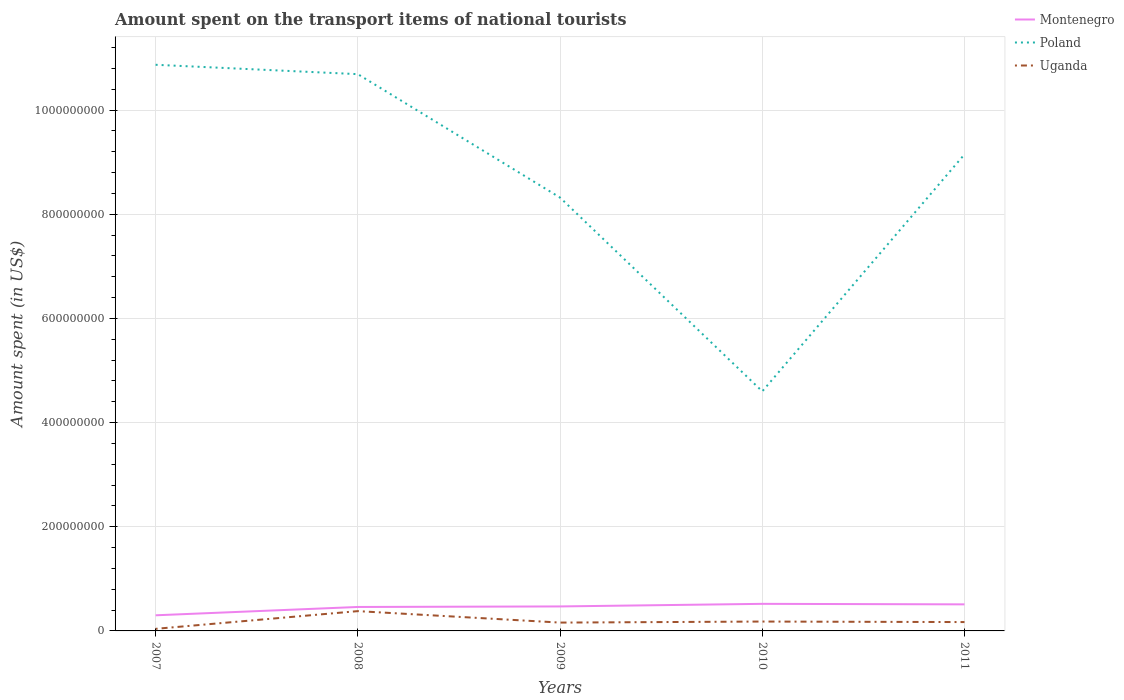How many different coloured lines are there?
Your response must be concise. 3. Is the number of lines equal to the number of legend labels?
Your answer should be compact. Yes. Across all years, what is the maximum amount spent on the transport items of national tourists in Poland?
Provide a succinct answer. 4.60e+08. In which year was the amount spent on the transport items of national tourists in Montenegro maximum?
Give a very brief answer. 2007. What is the total amount spent on the transport items of national tourists in Poland in the graph?
Ensure brevity in your answer.  2.37e+08. What is the difference between the highest and the second highest amount spent on the transport items of national tourists in Montenegro?
Provide a short and direct response. 2.20e+07. What is the difference between the highest and the lowest amount spent on the transport items of national tourists in Montenegro?
Your response must be concise. 4. Is the amount spent on the transport items of national tourists in Montenegro strictly greater than the amount spent on the transport items of national tourists in Poland over the years?
Make the answer very short. Yes. How many years are there in the graph?
Provide a succinct answer. 5. What is the difference between two consecutive major ticks on the Y-axis?
Offer a very short reply. 2.00e+08. How many legend labels are there?
Offer a very short reply. 3. What is the title of the graph?
Give a very brief answer. Amount spent on the transport items of national tourists. What is the label or title of the Y-axis?
Keep it short and to the point. Amount spent (in US$). What is the Amount spent (in US$) in Montenegro in 2007?
Offer a very short reply. 3.00e+07. What is the Amount spent (in US$) of Poland in 2007?
Your response must be concise. 1.09e+09. What is the Amount spent (in US$) in Montenegro in 2008?
Ensure brevity in your answer.  4.60e+07. What is the Amount spent (in US$) in Poland in 2008?
Your response must be concise. 1.07e+09. What is the Amount spent (in US$) of Uganda in 2008?
Ensure brevity in your answer.  3.80e+07. What is the Amount spent (in US$) in Montenegro in 2009?
Your answer should be compact. 4.70e+07. What is the Amount spent (in US$) of Poland in 2009?
Keep it short and to the point. 8.32e+08. What is the Amount spent (in US$) of Uganda in 2009?
Offer a terse response. 1.60e+07. What is the Amount spent (in US$) in Montenegro in 2010?
Make the answer very short. 5.20e+07. What is the Amount spent (in US$) in Poland in 2010?
Offer a very short reply. 4.60e+08. What is the Amount spent (in US$) of Uganda in 2010?
Your answer should be compact. 1.80e+07. What is the Amount spent (in US$) in Montenegro in 2011?
Make the answer very short. 5.10e+07. What is the Amount spent (in US$) in Poland in 2011?
Make the answer very short. 9.15e+08. What is the Amount spent (in US$) in Uganda in 2011?
Offer a terse response. 1.70e+07. Across all years, what is the maximum Amount spent (in US$) of Montenegro?
Give a very brief answer. 5.20e+07. Across all years, what is the maximum Amount spent (in US$) in Poland?
Your answer should be compact. 1.09e+09. Across all years, what is the maximum Amount spent (in US$) of Uganda?
Provide a succinct answer. 3.80e+07. Across all years, what is the minimum Amount spent (in US$) of Montenegro?
Offer a terse response. 3.00e+07. Across all years, what is the minimum Amount spent (in US$) of Poland?
Your answer should be very brief. 4.60e+08. What is the total Amount spent (in US$) of Montenegro in the graph?
Your answer should be compact. 2.26e+08. What is the total Amount spent (in US$) in Poland in the graph?
Your answer should be very brief. 4.36e+09. What is the total Amount spent (in US$) of Uganda in the graph?
Your answer should be compact. 9.30e+07. What is the difference between the Amount spent (in US$) of Montenegro in 2007 and that in 2008?
Make the answer very short. -1.60e+07. What is the difference between the Amount spent (in US$) in Poland in 2007 and that in 2008?
Keep it short and to the point. 1.80e+07. What is the difference between the Amount spent (in US$) in Uganda in 2007 and that in 2008?
Offer a very short reply. -3.40e+07. What is the difference between the Amount spent (in US$) of Montenegro in 2007 and that in 2009?
Keep it short and to the point. -1.70e+07. What is the difference between the Amount spent (in US$) in Poland in 2007 and that in 2009?
Your answer should be very brief. 2.55e+08. What is the difference between the Amount spent (in US$) of Uganda in 2007 and that in 2009?
Keep it short and to the point. -1.20e+07. What is the difference between the Amount spent (in US$) of Montenegro in 2007 and that in 2010?
Your answer should be very brief. -2.20e+07. What is the difference between the Amount spent (in US$) of Poland in 2007 and that in 2010?
Your answer should be very brief. 6.27e+08. What is the difference between the Amount spent (in US$) of Uganda in 2007 and that in 2010?
Make the answer very short. -1.40e+07. What is the difference between the Amount spent (in US$) in Montenegro in 2007 and that in 2011?
Provide a short and direct response. -2.10e+07. What is the difference between the Amount spent (in US$) in Poland in 2007 and that in 2011?
Your answer should be very brief. 1.72e+08. What is the difference between the Amount spent (in US$) of Uganda in 2007 and that in 2011?
Provide a short and direct response. -1.30e+07. What is the difference between the Amount spent (in US$) of Montenegro in 2008 and that in 2009?
Ensure brevity in your answer.  -1.00e+06. What is the difference between the Amount spent (in US$) in Poland in 2008 and that in 2009?
Make the answer very short. 2.37e+08. What is the difference between the Amount spent (in US$) in Uganda in 2008 and that in 2009?
Offer a very short reply. 2.20e+07. What is the difference between the Amount spent (in US$) in Montenegro in 2008 and that in 2010?
Provide a succinct answer. -6.00e+06. What is the difference between the Amount spent (in US$) of Poland in 2008 and that in 2010?
Offer a terse response. 6.09e+08. What is the difference between the Amount spent (in US$) of Uganda in 2008 and that in 2010?
Your answer should be compact. 2.00e+07. What is the difference between the Amount spent (in US$) of Montenegro in 2008 and that in 2011?
Your answer should be very brief. -5.00e+06. What is the difference between the Amount spent (in US$) in Poland in 2008 and that in 2011?
Ensure brevity in your answer.  1.54e+08. What is the difference between the Amount spent (in US$) in Uganda in 2008 and that in 2011?
Your answer should be compact. 2.10e+07. What is the difference between the Amount spent (in US$) of Montenegro in 2009 and that in 2010?
Give a very brief answer. -5.00e+06. What is the difference between the Amount spent (in US$) in Poland in 2009 and that in 2010?
Make the answer very short. 3.72e+08. What is the difference between the Amount spent (in US$) of Montenegro in 2009 and that in 2011?
Ensure brevity in your answer.  -4.00e+06. What is the difference between the Amount spent (in US$) in Poland in 2009 and that in 2011?
Your response must be concise. -8.30e+07. What is the difference between the Amount spent (in US$) in Uganda in 2009 and that in 2011?
Provide a short and direct response. -1.00e+06. What is the difference between the Amount spent (in US$) in Montenegro in 2010 and that in 2011?
Give a very brief answer. 1.00e+06. What is the difference between the Amount spent (in US$) of Poland in 2010 and that in 2011?
Ensure brevity in your answer.  -4.55e+08. What is the difference between the Amount spent (in US$) in Montenegro in 2007 and the Amount spent (in US$) in Poland in 2008?
Provide a succinct answer. -1.04e+09. What is the difference between the Amount spent (in US$) of Montenegro in 2007 and the Amount spent (in US$) of Uganda in 2008?
Offer a terse response. -8.00e+06. What is the difference between the Amount spent (in US$) of Poland in 2007 and the Amount spent (in US$) of Uganda in 2008?
Your response must be concise. 1.05e+09. What is the difference between the Amount spent (in US$) of Montenegro in 2007 and the Amount spent (in US$) of Poland in 2009?
Offer a very short reply. -8.02e+08. What is the difference between the Amount spent (in US$) of Montenegro in 2007 and the Amount spent (in US$) of Uganda in 2009?
Make the answer very short. 1.40e+07. What is the difference between the Amount spent (in US$) in Poland in 2007 and the Amount spent (in US$) in Uganda in 2009?
Keep it short and to the point. 1.07e+09. What is the difference between the Amount spent (in US$) of Montenegro in 2007 and the Amount spent (in US$) of Poland in 2010?
Your answer should be compact. -4.30e+08. What is the difference between the Amount spent (in US$) in Poland in 2007 and the Amount spent (in US$) in Uganda in 2010?
Offer a terse response. 1.07e+09. What is the difference between the Amount spent (in US$) in Montenegro in 2007 and the Amount spent (in US$) in Poland in 2011?
Keep it short and to the point. -8.85e+08. What is the difference between the Amount spent (in US$) in Montenegro in 2007 and the Amount spent (in US$) in Uganda in 2011?
Your response must be concise. 1.30e+07. What is the difference between the Amount spent (in US$) of Poland in 2007 and the Amount spent (in US$) of Uganda in 2011?
Give a very brief answer. 1.07e+09. What is the difference between the Amount spent (in US$) in Montenegro in 2008 and the Amount spent (in US$) in Poland in 2009?
Offer a terse response. -7.86e+08. What is the difference between the Amount spent (in US$) in Montenegro in 2008 and the Amount spent (in US$) in Uganda in 2009?
Your response must be concise. 3.00e+07. What is the difference between the Amount spent (in US$) in Poland in 2008 and the Amount spent (in US$) in Uganda in 2009?
Provide a succinct answer. 1.05e+09. What is the difference between the Amount spent (in US$) in Montenegro in 2008 and the Amount spent (in US$) in Poland in 2010?
Provide a short and direct response. -4.14e+08. What is the difference between the Amount spent (in US$) of Montenegro in 2008 and the Amount spent (in US$) of Uganda in 2010?
Keep it short and to the point. 2.80e+07. What is the difference between the Amount spent (in US$) in Poland in 2008 and the Amount spent (in US$) in Uganda in 2010?
Your answer should be compact. 1.05e+09. What is the difference between the Amount spent (in US$) of Montenegro in 2008 and the Amount spent (in US$) of Poland in 2011?
Your answer should be very brief. -8.69e+08. What is the difference between the Amount spent (in US$) of Montenegro in 2008 and the Amount spent (in US$) of Uganda in 2011?
Offer a terse response. 2.90e+07. What is the difference between the Amount spent (in US$) in Poland in 2008 and the Amount spent (in US$) in Uganda in 2011?
Ensure brevity in your answer.  1.05e+09. What is the difference between the Amount spent (in US$) of Montenegro in 2009 and the Amount spent (in US$) of Poland in 2010?
Provide a succinct answer. -4.13e+08. What is the difference between the Amount spent (in US$) in Montenegro in 2009 and the Amount spent (in US$) in Uganda in 2010?
Keep it short and to the point. 2.90e+07. What is the difference between the Amount spent (in US$) in Poland in 2009 and the Amount spent (in US$) in Uganda in 2010?
Your answer should be very brief. 8.14e+08. What is the difference between the Amount spent (in US$) of Montenegro in 2009 and the Amount spent (in US$) of Poland in 2011?
Ensure brevity in your answer.  -8.68e+08. What is the difference between the Amount spent (in US$) in Montenegro in 2009 and the Amount spent (in US$) in Uganda in 2011?
Keep it short and to the point. 3.00e+07. What is the difference between the Amount spent (in US$) in Poland in 2009 and the Amount spent (in US$) in Uganda in 2011?
Offer a very short reply. 8.15e+08. What is the difference between the Amount spent (in US$) in Montenegro in 2010 and the Amount spent (in US$) in Poland in 2011?
Provide a succinct answer. -8.63e+08. What is the difference between the Amount spent (in US$) in Montenegro in 2010 and the Amount spent (in US$) in Uganda in 2011?
Your answer should be compact. 3.50e+07. What is the difference between the Amount spent (in US$) of Poland in 2010 and the Amount spent (in US$) of Uganda in 2011?
Ensure brevity in your answer.  4.43e+08. What is the average Amount spent (in US$) of Montenegro per year?
Your answer should be compact. 4.52e+07. What is the average Amount spent (in US$) in Poland per year?
Your response must be concise. 8.73e+08. What is the average Amount spent (in US$) of Uganda per year?
Your response must be concise. 1.86e+07. In the year 2007, what is the difference between the Amount spent (in US$) of Montenegro and Amount spent (in US$) of Poland?
Make the answer very short. -1.06e+09. In the year 2007, what is the difference between the Amount spent (in US$) of Montenegro and Amount spent (in US$) of Uganda?
Provide a short and direct response. 2.60e+07. In the year 2007, what is the difference between the Amount spent (in US$) of Poland and Amount spent (in US$) of Uganda?
Keep it short and to the point. 1.08e+09. In the year 2008, what is the difference between the Amount spent (in US$) in Montenegro and Amount spent (in US$) in Poland?
Keep it short and to the point. -1.02e+09. In the year 2008, what is the difference between the Amount spent (in US$) of Montenegro and Amount spent (in US$) of Uganda?
Your answer should be compact. 8.00e+06. In the year 2008, what is the difference between the Amount spent (in US$) in Poland and Amount spent (in US$) in Uganda?
Provide a short and direct response. 1.03e+09. In the year 2009, what is the difference between the Amount spent (in US$) of Montenegro and Amount spent (in US$) of Poland?
Your answer should be compact. -7.85e+08. In the year 2009, what is the difference between the Amount spent (in US$) of Montenegro and Amount spent (in US$) of Uganda?
Make the answer very short. 3.10e+07. In the year 2009, what is the difference between the Amount spent (in US$) in Poland and Amount spent (in US$) in Uganda?
Keep it short and to the point. 8.16e+08. In the year 2010, what is the difference between the Amount spent (in US$) of Montenegro and Amount spent (in US$) of Poland?
Give a very brief answer. -4.08e+08. In the year 2010, what is the difference between the Amount spent (in US$) in Montenegro and Amount spent (in US$) in Uganda?
Give a very brief answer. 3.40e+07. In the year 2010, what is the difference between the Amount spent (in US$) in Poland and Amount spent (in US$) in Uganda?
Your response must be concise. 4.42e+08. In the year 2011, what is the difference between the Amount spent (in US$) in Montenegro and Amount spent (in US$) in Poland?
Provide a short and direct response. -8.64e+08. In the year 2011, what is the difference between the Amount spent (in US$) in Montenegro and Amount spent (in US$) in Uganda?
Your answer should be compact. 3.40e+07. In the year 2011, what is the difference between the Amount spent (in US$) of Poland and Amount spent (in US$) of Uganda?
Keep it short and to the point. 8.98e+08. What is the ratio of the Amount spent (in US$) of Montenegro in 2007 to that in 2008?
Give a very brief answer. 0.65. What is the ratio of the Amount spent (in US$) of Poland in 2007 to that in 2008?
Ensure brevity in your answer.  1.02. What is the ratio of the Amount spent (in US$) of Uganda in 2007 to that in 2008?
Offer a very short reply. 0.11. What is the ratio of the Amount spent (in US$) of Montenegro in 2007 to that in 2009?
Provide a succinct answer. 0.64. What is the ratio of the Amount spent (in US$) of Poland in 2007 to that in 2009?
Provide a short and direct response. 1.31. What is the ratio of the Amount spent (in US$) in Montenegro in 2007 to that in 2010?
Offer a terse response. 0.58. What is the ratio of the Amount spent (in US$) of Poland in 2007 to that in 2010?
Provide a short and direct response. 2.36. What is the ratio of the Amount spent (in US$) in Uganda in 2007 to that in 2010?
Provide a succinct answer. 0.22. What is the ratio of the Amount spent (in US$) of Montenegro in 2007 to that in 2011?
Ensure brevity in your answer.  0.59. What is the ratio of the Amount spent (in US$) in Poland in 2007 to that in 2011?
Make the answer very short. 1.19. What is the ratio of the Amount spent (in US$) of Uganda in 2007 to that in 2011?
Offer a very short reply. 0.24. What is the ratio of the Amount spent (in US$) of Montenegro in 2008 to that in 2009?
Provide a short and direct response. 0.98. What is the ratio of the Amount spent (in US$) in Poland in 2008 to that in 2009?
Keep it short and to the point. 1.28. What is the ratio of the Amount spent (in US$) of Uganda in 2008 to that in 2009?
Make the answer very short. 2.38. What is the ratio of the Amount spent (in US$) in Montenegro in 2008 to that in 2010?
Keep it short and to the point. 0.88. What is the ratio of the Amount spent (in US$) in Poland in 2008 to that in 2010?
Your answer should be compact. 2.32. What is the ratio of the Amount spent (in US$) in Uganda in 2008 to that in 2010?
Your response must be concise. 2.11. What is the ratio of the Amount spent (in US$) of Montenegro in 2008 to that in 2011?
Offer a very short reply. 0.9. What is the ratio of the Amount spent (in US$) in Poland in 2008 to that in 2011?
Provide a short and direct response. 1.17. What is the ratio of the Amount spent (in US$) of Uganda in 2008 to that in 2011?
Provide a short and direct response. 2.24. What is the ratio of the Amount spent (in US$) in Montenegro in 2009 to that in 2010?
Your answer should be compact. 0.9. What is the ratio of the Amount spent (in US$) of Poland in 2009 to that in 2010?
Make the answer very short. 1.81. What is the ratio of the Amount spent (in US$) in Montenegro in 2009 to that in 2011?
Your answer should be very brief. 0.92. What is the ratio of the Amount spent (in US$) of Poland in 2009 to that in 2011?
Provide a succinct answer. 0.91. What is the ratio of the Amount spent (in US$) in Montenegro in 2010 to that in 2011?
Ensure brevity in your answer.  1.02. What is the ratio of the Amount spent (in US$) of Poland in 2010 to that in 2011?
Make the answer very short. 0.5. What is the ratio of the Amount spent (in US$) of Uganda in 2010 to that in 2011?
Your answer should be very brief. 1.06. What is the difference between the highest and the second highest Amount spent (in US$) in Poland?
Provide a succinct answer. 1.80e+07. What is the difference between the highest and the lowest Amount spent (in US$) in Montenegro?
Offer a very short reply. 2.20e+07. What is the difference between the highest and the lowest Amount spent (in US$) in Poland?
Make the answer very short. 6.27e+08. What is the difference between the highest and the lowest Amount spent (in US$) of Uganda?
Your answer should be very brief. 3.40e+07. 